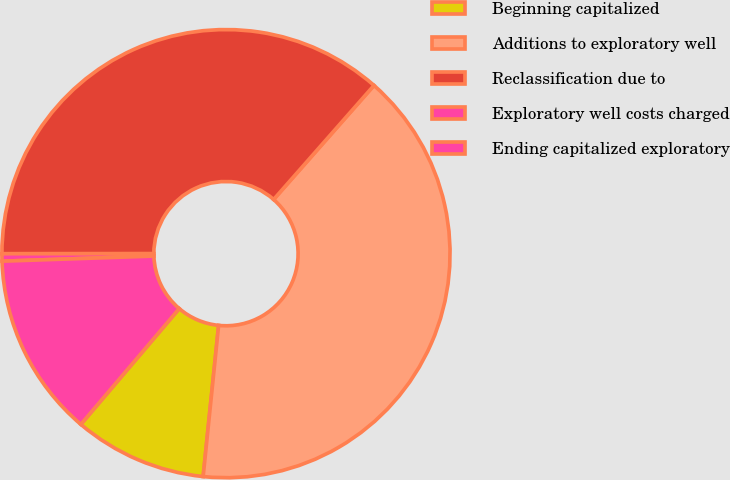Convert chart to OTSL. <chart><loc_0><loc_0><loc_500><loc_500><pie_chart><fcel>Beginning capitalized<fcel>Additions to exploratory well<fcel>Reclassification due to<fcel>Exploratory well costs charged<fcel>Ending capitalized exploratory<nl><fcel>9.59%<fcel>40.14%<fcel>36.49%<fcel>0.53%<fcel>13.25%<nl></chart> 